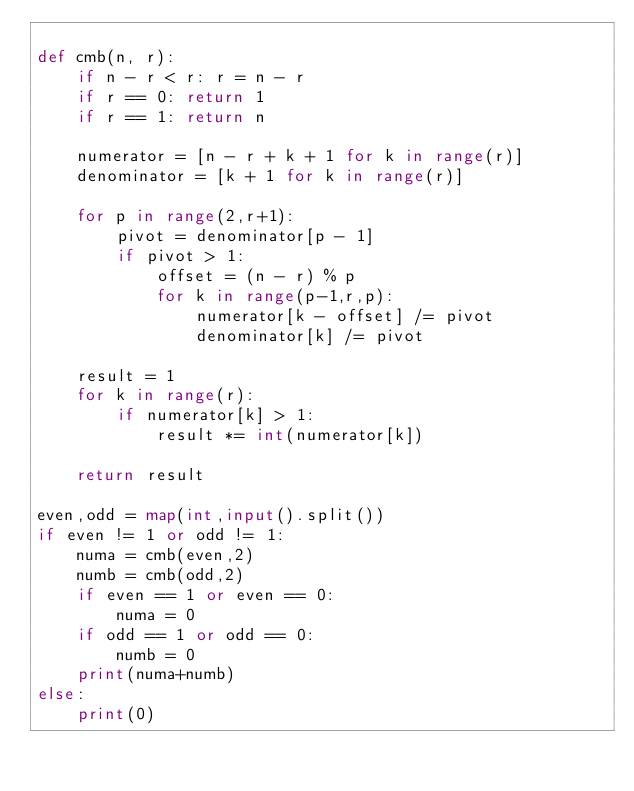<code> <loc_0><loc_0><loc_500><loc_500><_Python_>
def cmb(n, r):
    if n - r < r: r = n - r
    if r == 0: return 1
    if r == 1: return n

    numerator = [n - r + k + 1 for k in range(r)]
    denominator = [k + 1 for k in range(r)]

    for p in range(2,r+1):
        pivot = denominator[p - 1]
        if pivot > 1:
            offset = (n - r) % p
            for k in range(p-1,r,p):
                numerator[k - offset] /= pivot
                denominator[k] /= pivot

    result = 1
    for k in range(r):
        if numerator[k] > 1:
            result *= int(numerator[k])

    return result

even,odd = map(int,input().split())
if even != 1 or odd != 1:
    numa = cmb(even,2)
    numb = cmb(odd,2)
    if even == 1 or even == 0:
        numa = 0
    if odd == 1 or odd == 0:
        numb = 0
    print(numa+numb)
else:
    print(0)



</code> 